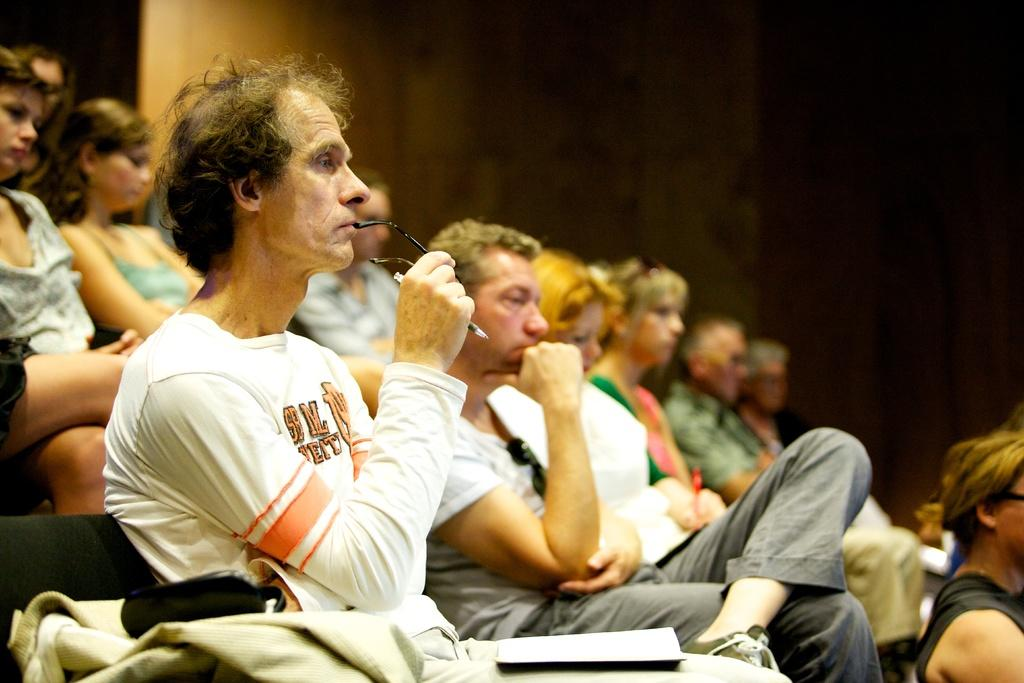What are the people in the image doing? The people in the image are sitting. What object related to reading can be seen in the image? There is a book in the image. What type of material is present in the image? There is a cloth in the image. What can be seen in the background of the image? There is a wall in the background of the image. What type of voyage is the stranger embarking on in the image? There is no stranger or voyage present in the image; it only features people sitting, a book, a cloth, and a wall in the background. 